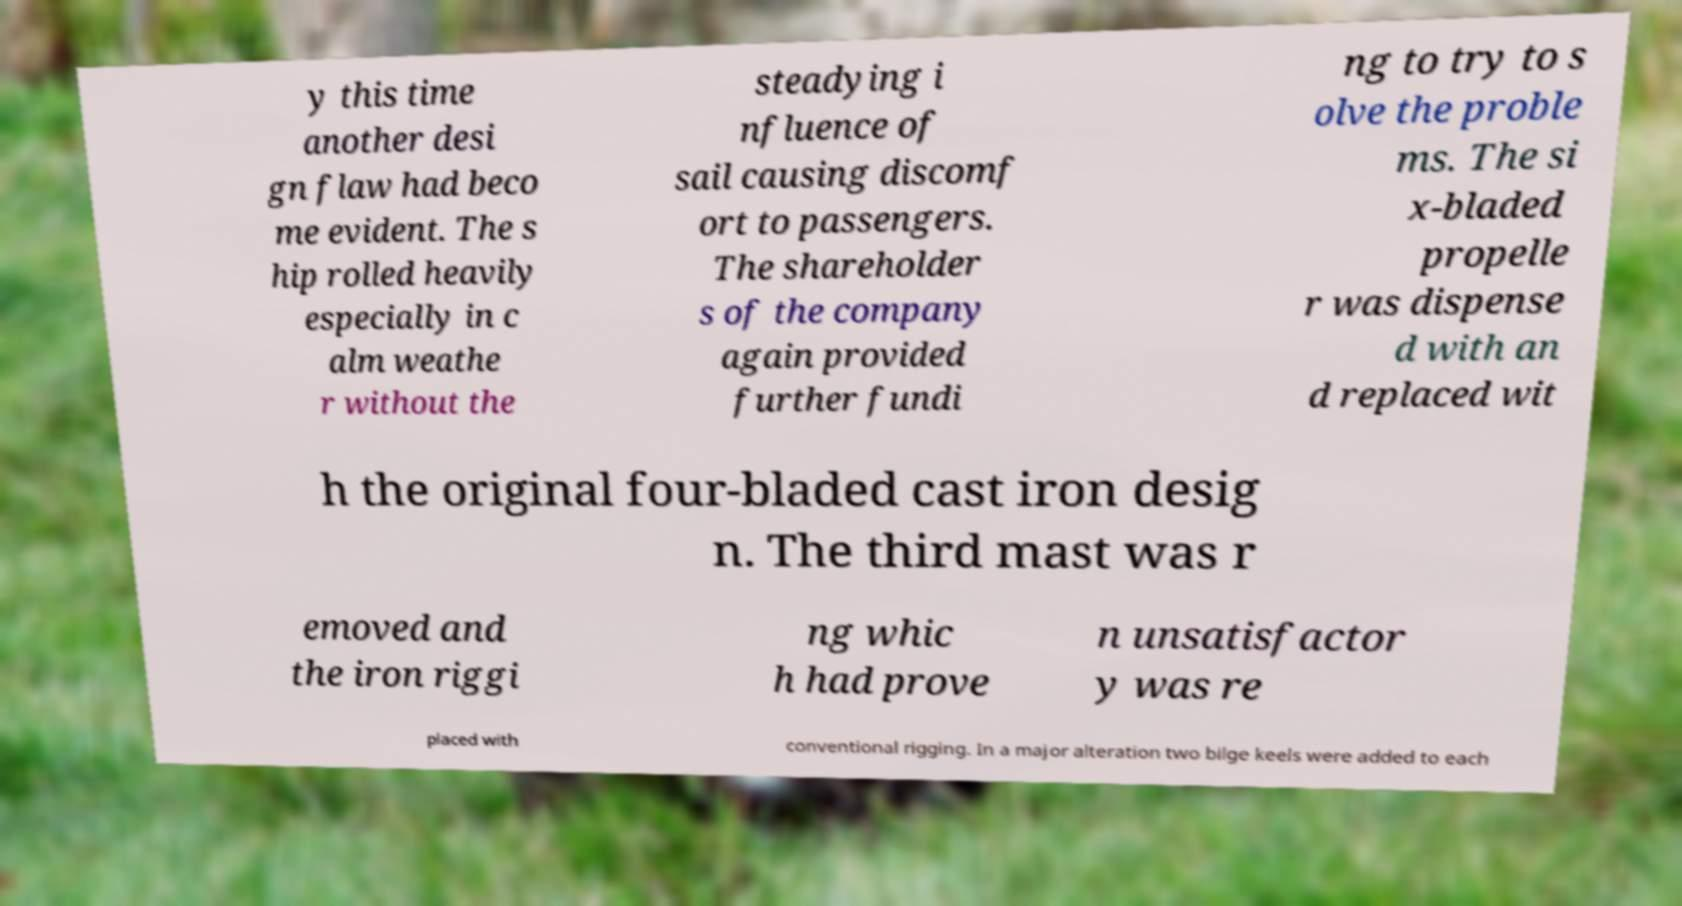Can you read and provide the text displayed in the image?This photo seems to have some interesting text. Can you extract and type it out for me? y this time another desi gn flaw had beco me evident. The s hip rolled heavily especially in c alm weathe r without the steadying i nfluence of sail causing discomf ort to passengers. The shareholder s of the company again provided further fundi ng to try to s olve the proble ms. The si x-bladed propelle r was dispense d with an d replaced wit h the original four-bladed cast iron desig n. The third mast was r emoved and the iron riggi ng whic h had prove n unsatisfactor y was re placed with conventional rigging. In a major alteration two bilge keels were added to each 